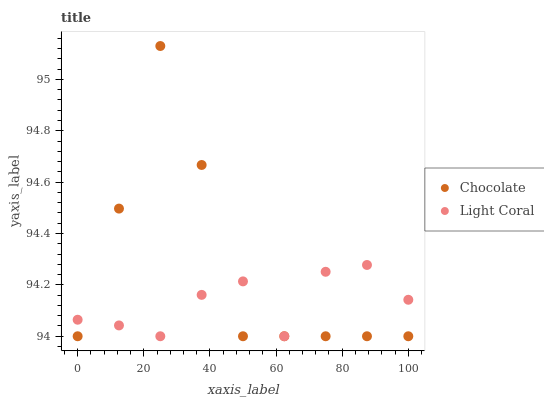Does Light Coral have the minimum area under the curve?
Answer yes or no. Yes. Does Chocolate have the maximum area under the curve?
Answer yes or no. Yes. Does Chocolate have the minimum area under the curve?
Answer yes or no. No. Is Light Coral the smoothest?
Answer yes or no. Yes. Is Chocolate the roughest?
Answer yes or no. Yes. Is Chocolate the smoothest?
Answer yes or no. No. Does Light Coral have the lowest value?
Answer yes or no. Yes. Does Chocolate have the highest value?
Answer yes or no. Yes. Does Chocolate intersect Light Coral?
Answer yes or no. Yes. Is Chocolate less than Light Coral?
Answer yes or no. No. Is Chocolate greater than Light Coral?
Answer yes or no. No. 